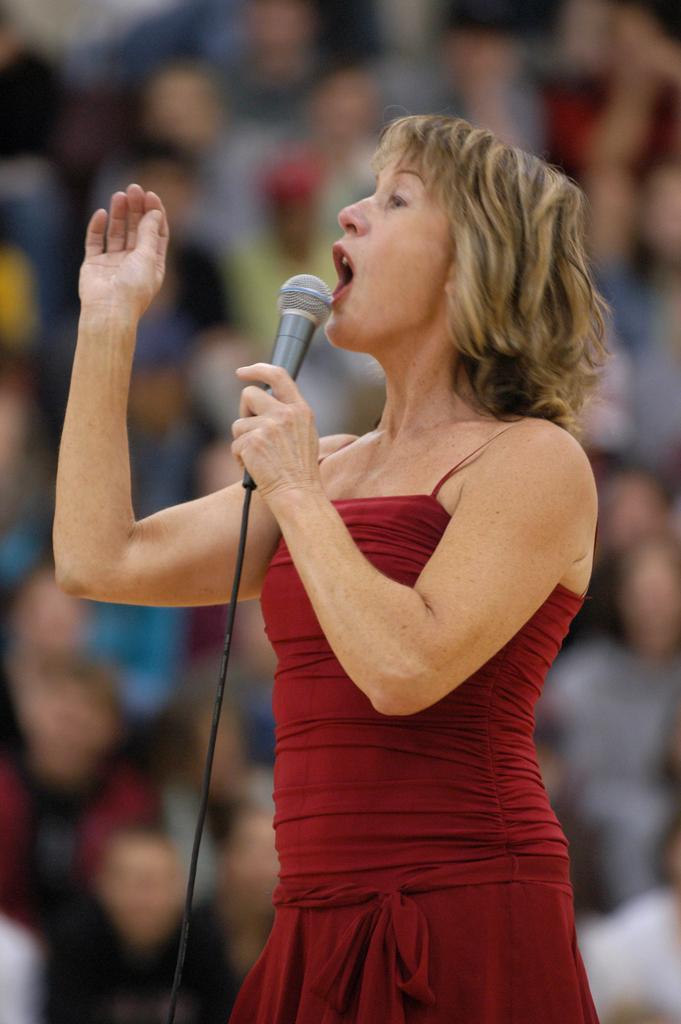Please provide a concise description of this image. This picture shows a woman, holding a mic in her hand and standing. She is talking. In the background there are some people sitting and watching. 